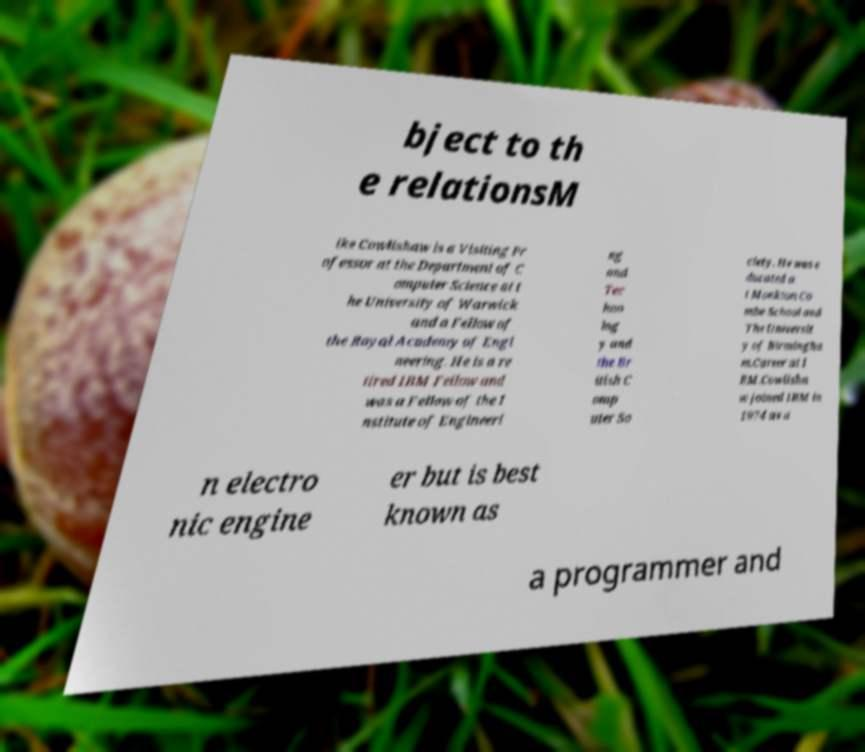For documentation purposes, I need the text within this image transcribed. Could you provide that? bject to th e relationsM ike Cowlishaw is a Visiting Pr ofessor at the Department of C omputer Science at t he University of Warwick and a Fellow of the Royal Academy of Engi neering. He is a re tired IBM Fellow and was a Fellow of the I nstitute of Engineeri ng and Tec hno log y and the Br itish C omp uter So ciety. He was e ducated a t Monkton Co mbe School and The Universit y of Birmingha m.Career at I BM.Cowlisha w joined IBM in 1974 as a n electro nic engine er but is best known as a programmer and 